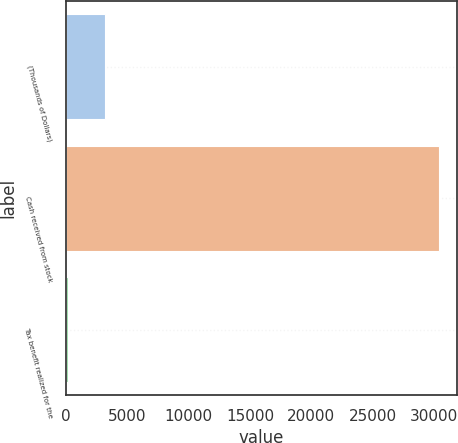Convert chart. <chart><loc_0><loc_0><loc_500><loc_500><bar_chart><fcel>(Thousands of Dollars)<fcel>Cash received from stock<fcel>Tax benefit realized for the<nl><fcel>3179.4<fcel>30381<fcel>157<nl></chart> 